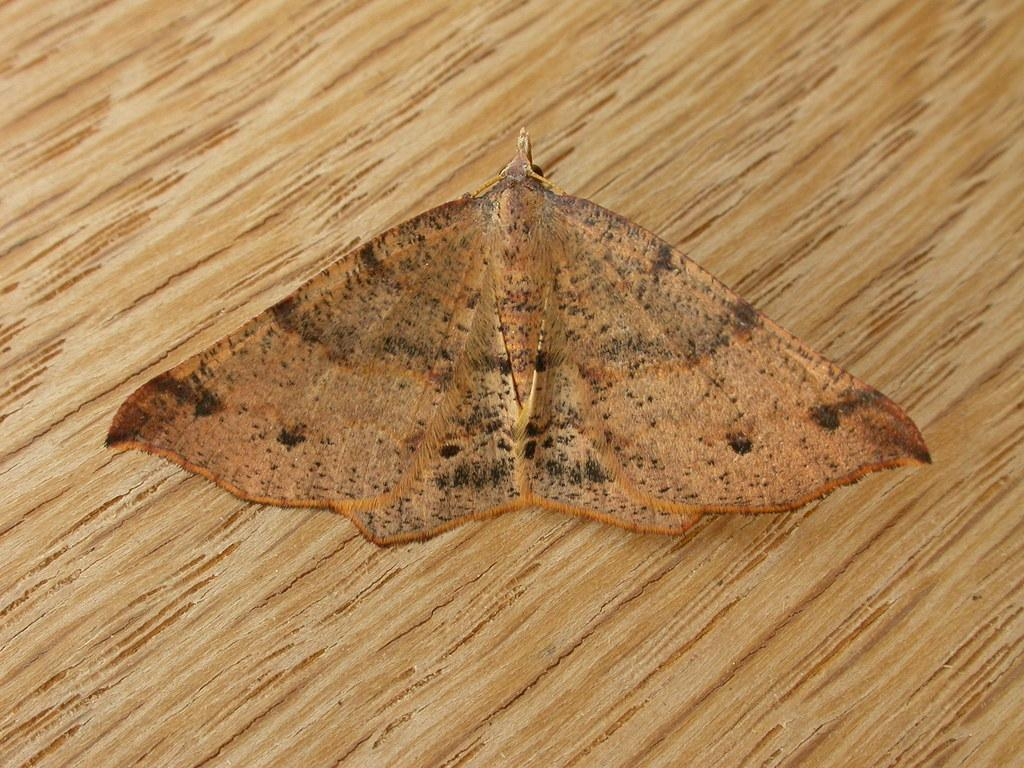What is the main subject of the image? There is a butterfly in the image. Where is the butterfly located? The butterfly is on a wooden surface. Reasoning: Let's think step by identifying the main subject and its location in the image. We start by mentioning the butterfly as the main subject and then describe its location, which is on a wooden surface. We keep the language simple and clear, and the questions can be answered definitively with the information given. Absurd Question/Answer: How many times has the butterfly given birth in the image? There is no indication of the butterfly giving birth in the image, as butterflies do not give birth. What is the coastline like in the image? There is no coastline present in the image, as it features a butterfly on a wooden surface. 